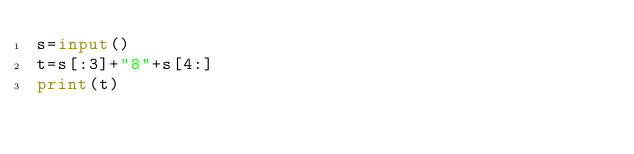Convert code to text. <code><loc_0><loc_0><loc_500><loc_500><_Python_>s=input()
t=s[:3]+"8"+s[4:]
print(t)</code> 